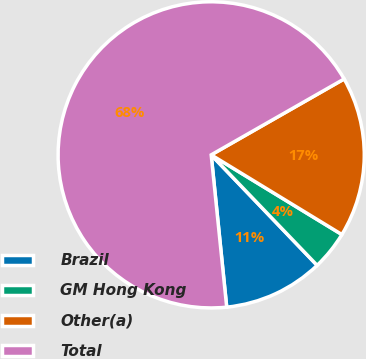Convert chart. <chart><loc_0><loc_0><loc_500><loc_500><pie_chart><fcel>Brazil<fcel>GM Hong Kong<fcel>Other(a)<fcel>Total<nl><fcel>10.55%<fcel>4.12%<fcel>16.97%<fcel>68.36%<nl></chart> 